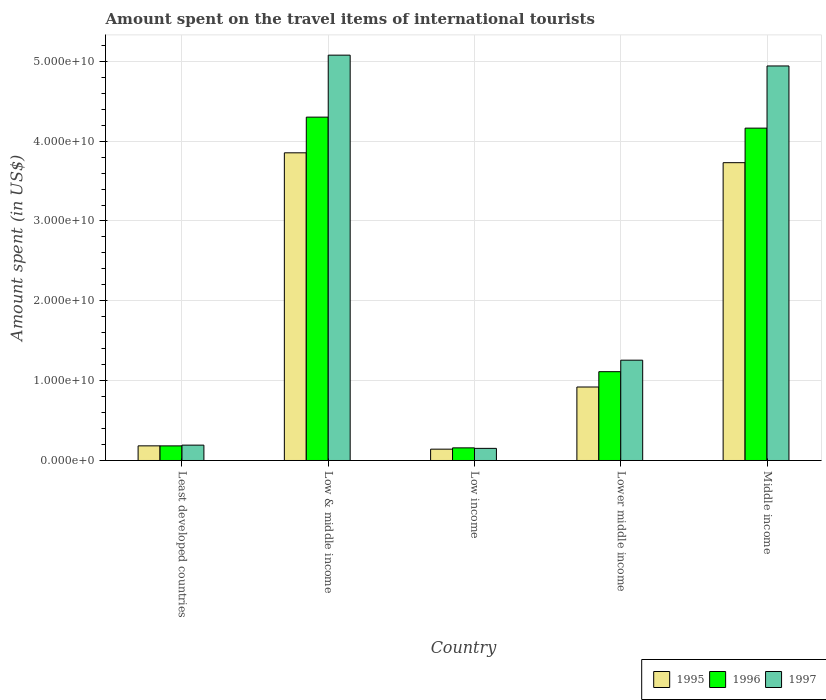How many different coloured bars are there?
Your answer should be compact. 3. How many groups of bars are there?
Ensure brevity in your answer.  5. Are the number of bars per tick equal to the number of legend labels?
Your response must be concise. Yes. What is the label of the 1st group of bars from the left?
Your answer should be very brief. Least developed countries. In how many cases, is the number of bars for a given country not equal to the number of legend labels?
Make the answer very short. 0. What is the amount spent on the travel items of international tourists in 1996 in Least developed countries?
Provide a succinct answer. 1.83e+09. Across all countries, what is the maximum amount spent on the travel items of international tourists in 1997?
Offer a very short reply. 5.08e+1. Across all countries, what is the minimum amount spent on the travel items of international tourists in 1996?
Provide a succinct answer. 1.58e+09. What is the total amount spent on the travel items of international tourists in 1996 in the graph?
Provide a succinct answer. 9.92e+1. What is the difference between the amount spent on the travel items of international tourists in 1997 in Least developed countries and that in Low & middle income?
Your answer should be compact. -4.88e+1. What is the difference between the amount spent on the travel items of international tourists in 1997 in Low income and the amount spent on the travel items of international tourists in 1995 in Least developed countries?
Your answer should be very brief. -3.15e+08. What is the average amount spent on the travel items of international tourists in 1995 per country?
Your answer should be very brief. 1.77e+1. What is the difference between the amount spent on the travel items of international tourists of/in 1996 and amount spent on the travel items of international tourists of/in 1995 in Low income?
Ensure brevity in your answer.  1.63e+08. What is the ratio of the amount spent on the travel items of international tourists in 1996 in Least developed countries to that in Lower middle income?
Your answer should be very brief. 0.16. Is the amount spent on the travel items of international tourists in 1996 in Least developed countries less than that in Low & middle income?
Provide a short and direct response. Yes. What is the difference between the highest and the second highest amount spent on the travel items of international tourists in 1997?
Keep it short and to the point. -3.69e+1. What is the difference between the highest and the lowest amount spent on the travel items of international tourists in 1995?
Provide a succinct answer. 3.71e+1. In how many countries, is the amount spent on the travel items of international tourists in 1996 greater than the average amount spent on the travel items of international tourists in 1996 taken over all countries?
Your response must be concise. 2. Is the sum of the amount spent on the travel items of international tourists in 1996 in Low income and Middle income greater than the maximum amount spent on the travel items of international tourists in 1997 across all countries?
Make the answer very short. No. Is it the case that in every country, the sum of the amount spent on the travel items of international tourists in 1996 and amount spent on the travel items of international tourists in 1997 is greater than the amount spent on the travel items of international tourists in 1995?
Your answer should be very brief. Yes. How many bars are there?
Provide a short and direct response. 15. Are all the bars in the graph horizontal?
Provide a short and direct response. No. How many countries are there in the graph?
Make the answer very short. 5. What is the difference between two consecutive major ticks on the Y-axis?
Your answer should be compact. 1.00e+1. Does the graph contain any zero values?
Provide a short and direct response. No. Where does the legend appear in the graph?
Your answer should be very brief. Bottom right. How many legend labels are there?
Offer a terse response. 3. What is the title of the graph?
Give a very brief answer. Amount spent on the travel items of international tourists. Does "2010" appear as one of the legend labels in the graph?
Provide a succinct answer. No. What is the label or title of the Y-axis?
Offer a terse response. Amount spent (in US$). What is the Amount spent (in US$) of 1995 in Least developed countries?
Offer a terse response. 1.83e+09. What is the Amount spent (in US$) of 1996 in Least developed countries?
Give a very brief answer. 1.83e+09. What is the Amount spent (in US$) in 1997 in Least developed countries?
Make the answer very short. 1.92e+09. What is the Amount spent (in US$) of 1995 in Low & middle income?
Keep it short and to the point. 3.85e+1. What is the Amount spent (in US$) of 1996 in Low & middle income?
Give a very brief answer. 4.30e+1. What is the Amount spent (in US$) of 1997 in Low & middle income?
Your response must be concise. 5.08e+1. What is the Amount spent (in US$) of 1995 in Low income?
Give a very brief answer. 1.42e+09. What is the Amount spent (in US$) of 1996 in Low income?
Your response must be concise. 1.58e+09. What is the Amount spent (in US$) of 1997 in Low income?
Your response must be concise. 1.52e+09. What is the Amount spent (in US$) of 1995 in Lower middle income?
Make the answer very short. 9.20e+09. What is the Amount spent (in US$) of 1996 in Lower middle income?
Keep it short and to the point. 1.11e+1. What is the Amount spent (in US$) in 1997 in Lower middle income?
Give a very brief answer. 1.26e+1. What is the Amount spent (in US$) in 1995 in Middle income?
Your answer should be very brief. 3.73e+1. What is the Amount spent (in US$) of 1996 in Middle income?
Offer a terse response. 4.16e+1. What is the Amount spent (in US$) of 1997 in Middle income?
Your response must be concise. 4.94e+1. Across all countries, what is the maximum Amount spent (in US$) in 1995?
Ensure brevity in your answer.  3.85e+1. Across all countries, what is the maximum Amount spent (in US$) of 1996?
Give a very brief answer. 4.30e+1. Across all countries, what is the maximum Amount spent (in US$) of 1997?
Provide a short and direct response. 5.08e+1. Across all countries, what is the minimum Amount spent (in US$) in 1995?
Ensure brevity in your answer.  1.42e+09. Across all countries, what is the minimum Amount spent (in US$) of 1996?
Offer a very short reply. 1.58e+09. Across all countries, what is the minimum Amount spent (in US$) in 1997?
Provide a short and direct response. 1.52e+09. What is the total Amount spent (in US$) of 1995 in the graph?
Make the answer very short. 8.83e+1. What is the total Amount spent (in US$) of 1996 in the graph?
Provide a short and direct response. 9.92e+1. What is the total Amount spent (in US$) in 1997 in the graph?
Your answer should be compact. 1.16e+11. What is the difference between the Amount spent (in US$) in 1995 in Least developed countries and that in Low & middle income?
Your answer should be very brief. -3.67e+1. What is the difference between the Amount spent (in US$) in 1996 in Least developed countries and that in Low & middle income?
Keep it short and to the point. -4.12e+1. What is the difference between the Amount spent (in US$) in 1997 in Least developed countries and that in Low & middle income?
Your response must be concise. -4.88e+1. What is the difference between the Amount spent (in US$) of 1995 in Least developed countries and that in Low income?
Your answer should be very brief. 4.16e+08. What is the difference between the Amount spent (in US$) of 1996 in Least developed countries and that in Low income?
Your response must be concise. 2.48e+08. What is the difference between the Amount spent (in US$) in 1997 in Least developed countries and that in Low income?
Ensure brevity in your answer.  4.05e+08. What is the difference between the Amount spent (in US$) of 1995 in Least developed countries and that in Lower middle income?
Your response must be concise. -7.37e+09. What is the difference between the Amount spent (in US$) in 1996 in Least developed countries and that in Lower middle income?
Ensure brevity in your answer.  -9.30e+09. What is the difference between the Amount spent (in US$) of 1997 in Least developed countries and that in Lower middle income?
Offer a very short reply. -1.06e+1. What is the difference between the Amount spent (in US$) of 1995 in Least developed countries and that in Middle income?
Give a very brief answer. -3.55e+1. What is the difference between the Amount spent (in US$) of 1996 in Least developed countries and that in Middle income?
Provide a short and direct response. -3.98e+1. What is the difference between the Amount spent (in US$) of 1997 in Least developed countries and that in Middle income?
Provide a short and direct response. -4.75e+1. What is the difference between the Amount spent (in US$) in 1995 in Low & middle income and that in Low income?
Ensure brevity in your answer.  3.71e+1. What is the difference between the Amount spent (in US$) in 1996 in Low & middle income and that in Low income?
Offer a terse response. 4.14e+1. What is the difference between the Amount spent (in US$) of 1997 in Low & middle income and that in Low income?
Offer a terse response. 4.93e+1. What is the difference between the Amount spent (in US$) in 1995 in Low & middle income and that in Lower middle income?
Your response must be concise. 2.93e+1. What is the difference between the Amount spent (in US$) in 1996 in Low & middle income and that in Lower middle income?
Keep it short and to the point. 3.19e+1. What is the difference between the Amount spent (in US$) in 1997 in Low & middle income and that in Lower middle income?
Offer a terse response. 3.82e+1. What is the difference between the Amount spent (in US$) in 1995 in Low & middle income and that in Middle income?
Your answer should be very brief. 1.24e+09. What is the difference between the Amount spent (in US$) of 1996 in Low & middle income and that in Middle income?
Offer a very short reply. 1.38e+09. What is the difference between the Amount spent (in US$) in 1997 in Low & middle income and that in Middle income?
Offer a very short reply. 1.36e+09. What is the difference between the Amount spent (in US$) in 1995 in Low income and that in Lower middle income?
Keep it short and to the point. -7.79e+09. What is the difference between the Amount spent (in US$) in 1996 in Low income and that in Lower middle income?
Give a very brief answer. -9.54e+09. What is the difference between the Amount spent (in US$) of 1997 in Low income and that in Lower middle income?
Offer a very short reply. -1.10e+1. What is the difference between the Amount spent (in US$) of 1995 in Low income and that in Middle income?
Offer a very short reply. -3.59e+1. What is the difference between the Amount spent (in US$) in 1996 in Low income and that in Middle income?
Your answer should be compact. -4.00e+1. What is the difference between the Amount spent (in US$) in 1997 in Low income and that in Middle income?
Offer a terse response. -4.79e+1. What is the difference between the Amount spent (in US$) in 1995 in Lower middle income and that in Middle income?
Your response must be concise. -2.81e+1. What is the difference between the Amount spent (in US$) of 1996 in Lower middle income and that in Middle income?
Your response must be concise. -3.05e+1. What is the difference between the Amount spent (in US$) in 1997 in Lower middle income and that in Middle income?
Your response must be concise. -3.69e+1. What is the difference between the Amount spent (in US$) in 1995 in Least developed countries and the Amount spent (in US$) in 1996 in Low & middle income?
Your answer should be compact. -4.12e+1. What is the difference between the Amount spent (in US$) in 1995 in Least developed countries and the Amount spent (in US$) in 1997 in Low & middle income?
Offer a very short reply. -4.89e+1. What is the difference between the Amount spent (in US$) in 1996 in Least developed countries and the Amount spent (in US$) in 1997 in Low & middle income?
Your answer should be compact. -4.89e+1. What is the difference between the Amount spent (in US$) in 1995 in Least developed countries and the Amount spent (in US$) in 1996 in Low income?
Ensure brevity in your answer.  2.52e+08. What is the difference between the Amount spent (in US$) of 1995 in Least developed countries and the Amount spent (in US$) of 1997 in Low income?
Ensure brevity in your answer.  3.15e+08. What is the difference between the Amount spent (in US$) in 1996 in Least developed countries and the Amount spent (in US$) in 1997 in Low income?
Keep it short and to the point. 3.11e+08. What is the difference between the Amount spent (in US$) in 1995 in Least developed countries and the Amount spent (in US$) in 1996 in Lower middle income?
Make the answer very short. -9.29e+09. What is the difference between the Amount spent (in US$) of 1995 in Least developed countries and the Amount spent (in US$) of 1997 in Lower middle income?
Offer a terse response. -1.07e+1. What is the difference between the Amount spent (in US$) in 1996 in Least developed countries and the Amount spent (in US$) in 1997 in Lower middle income?
Offer a very short reply. -1.07e+1. What is the difference between the Amount spent (in US$) of 1995 in Least developed countries and the Amount spent (in US$) of 1996 in Middle income?
Provide a short and direct response. -3.98e+1. What is the difference between the Amount spent (in US$) in 1995 in Least developed countries and the Amount spent (in US$) in 1997 in Middle income?
Make the answer very short. -4.76e+1. What is the difference between the Amount spent (in US$) in 1996 in Least developed countries and the Amount spent (in US$) in 1997 in Middle income?
Make the answer very short. -4.76e+1. What is the difference between the Amount spent (in US$) of 1995 in Low & middle income and the Amount spent (in US$) of 1996 in Low income?
Offer a very short reply. 3.70e+1. What is the difference between the Amount spent (in US$) of 1995 in Low & middle income and the Amount spent (in US$) of 1997 in Low income?
Ensure brevity in your answer.  3.70e+1. What is the difference between the Amount spent (in US$) in 1996 in Low & middle income and the Amount spent (in US$) in 1997 in Low income?
Provide a short and direct response. 4.15e+1. What is the difference between the Amount spent (in US$) in 1995 in Low & middle income and the Amount spent (in US$) in 1996 in Lower middle income?
Provide a short and direct response. 2.74e+1. What is the difference between the Amount spent (in US$) in 1995 in Low & middle income and the Amount spent (in US$) in 1997 in Lower middle income?
Your response must be concise. 2.60e+1. What is the difference between the Amount spent (in US$) of 1996 in Low & middle income and the Amount spent (in US$) of 1997 in Lower middle income?
Provide a succinct answer. 3.04e+1. What is the difference between the Amount spent (in US$) of 1995 in Low & middle income and the Amount spent (in US$) of 1996 in Middle income?
Give a very brief answer. -3.09e+09. What is the difference between the Amount spent (in US$) in 1995 in Low & middle income and the Amount spent (in US$) in 1997 in Middle income?
Your response must be concise. -1.09e+1. What is the difference between the Amount spent (in US$) in 1996 in Low & middle income and the Amount spent (in US$) in 1997 in Middle income?
Make the answer very short. -6.41e+09. What is the difference between the Amount spent (in US$) of 1995 in Low income and the Amount spent (in US$) of 1996 in Lower middle income?
Your answer should be very brief. -9.71e+09. What is the difference between the Amount spent (in US$) of 1995 in Low income and the Amount spent (in US$) of 1997 in Lower middle income?
Keep it short and to the point. -1.11e+1. What is the difference between the Amount spent (in US$) of 1996 in Low income and the Amount spent (in US$) of 1997 in Lower middle income?
Give a very brief answer. -1.10e+1. What is the difference between the Amount spent (in US$) of 1995 in Low income and the Amount spent (in US$) of 1996 in Middle income?
Offer a terse response. -4.02e+1. What is the difference between the Amount spent (in US$) of 1995 in Low income and the Amount spent (in US$) of 1997 in Middle income?
Your response must be concise. -4.80e+1. What is the difference between the Amount spent (in US$) in 1996 in Low income and the Amount spent (in US$) in 1997 in Middle income?
Offer a very short reply. -4.78e+1. What is the difference between the Amount spent (in US$) in 1995 in Lower middle income and the Amount spent (in US$) in 1996 in Middle income?
Offer a very short reply. -3.24e+1. What is the difference between the Amount spent (in US$) in 1995 in Lower middle income and the Amount spent (in US$) in 1997 in Middle income?
Give a very brief answer. -4.02e+1. What is the difference between the Amount spent (in US$) of 1996 in Lower middle income and the Amount spent (in US$) of 1997 in Middle income?
Give a very brief answer. -3.83e+1. What is the average Amount spent (in US$) of 1995 per country?
Make the answer very short. 1.77e+1. What is the average Amount spent (in US$) of 1996 per country?
Give a very brief answer. 1.98e+1. What is the average Amount spent (in US$) of 1997 per country?
Give a very brief answer. 2.32e+1. What is the difference between the Amount spent (in US$) in 1995 and Amount spent (in US$) in 1996 in Least developed countries?
Your response must be concise. 4.74e+06. What is the difference between the Amount spent (in US$) in 1995 and Amount spent (in US$) in 1997 in Least developed countries?
Keep it short and to the point. -9.00e+07. What is the difference between the Amount spent (in US$) in 1996 and Amount spent (in US$) in 1997 in Least developed countries?
Ensure brevity in your answer.  -9.47e+07. What is the difference between the Amount spent (in US$) in 1995 and Amount spent (in US$) in 1996 in Low & middle income?
Keep it short and to the point. -4.47e+09. What is the difference between the Amount spent (in US$) of 1995 and Amount spent (in US$) of 1997 in Low & middle income?
Give a very brief answer. -1.22e+1. What is the difference between the Amount spent (in US$) in 1996 and Amount spent (in US$) in 1997 in Low & middle income?
Keep it short and to the point. -7.77e+09. What is the difference between the Amount spent (in US$) in 1995 and Amount spent (in US$) in 1996 in Low income?
Your response must be concise. -1.63e+08. What is the difference between the Amount spent (in US$) of 1995 and Amount spent (in US$) of 1997 in Low income?
Offer a terse response. -1.00e+08. What is the difference between the Amount spent (in US$) of 1996 and Amount spent (in US$) of 1997 in Low income?
Keep it short and to the point. 6.31e+07. What is the difference between the Amount spent (in US$) in 1995 and Amount spent (in US$) in 1996 in Lower middle income?
Offer a terse response. -1.92e+09. What is the difference between the Amount spent (in US$) of 1995 and Amount spent (in US$) of 1997 in Lower middle income?
Offer a very short reply. -3.36e+09. What is the difference between the Amount spent (in US$) in 1996 and Amount spent (in US$) in 1997 in Lower middle income?
Make the answer very short. -1.44e+09. What is the difference between the Amount spent (in US$) in 1995 and Amount spent (in US$) in 1996 in Middle income?
Your response must be concise. -4.33e+09. What is the difference between the Amount spent (in US$) in 1995 and Amount spent (in US$) in 1997 in Middle income?
Provide a short and direct response. -1.21e+1. What is the difference between the Amount spent (in US$) of 1996 and Amount spent (in US$) of 1997 in Middle income?
Offer a terse response. -7.79e+09. What is the ratio of the Amount spent (in US$) in 1995 in Least developed countries to that in Low & middle income?
Your answer should be compact. 0.05. What is the ratio of the Amount spent (in US$) of 1996 in Least developed countries to that in Low & middle income?
Your answer should be compact. 0.04. What is the ratio of the Amount spent (in US$) of 1997 in Least developed countries to that in Low & middle income?
Your response must be concise. 0.04. What is the ratio of the Amount spent (in US$) in 1995 in Least developed countries to that in Low income?
Keep it short and to the point. 1.29. What is the ratio of the Amount spent (in US$) of 1996 in Least developed countries to that in Low income?
Offer a terse response. 1.16. What is the ratio of the Amount spent (in US$) in 1997 in Least developed countries to that in Low income?
Your answer should be very brief. 1.27. What is the ratio of the Amount spent (in US$) in 1995 in Least developed countries to that in Lower middle income?
Keep it short and to the point. 0.2. What is the ratio of the Amount spent (in US$) in 1996 in Least developed countries to that in Lower middle income?
Ensure brevity in your answer.  0.16. What is the ratio of the Amount spent (in US$) of 1997 in Least developed countries to that in Lower middle income?
Provide a short and direct response. 0.15. What is the ratio of the Amount spent (in US$) of 1995 in Least developed countries to that in Middle income?
Keep it short and to the point. 0.05. What is the ratio of the Amount spent (in US$) of 1996 in Least developed countries to that in Middle income?
Your answer should be very brief. 0.04. What is the ratio of the Amount spent (in US$) in 1997 in Least developed countries to that in Middle income?
Provide a succinct answer. 0.04. What is the ratio of the Amount spent (in US$) of 1995 in Low & middle income to that in Low income?
Your response must be concise. 27.18. What is the ratio of the Amount spent (in US$) of 1996 in Low & middle income to that in Low income?
Make the answer very short. 27.2. What is the ratio of the Amount spent (in US$) of 1997 in Low & middle income to that in Low income?
Make the answer very short. 33.45. What is the ratio of the Amount spent (in US$) of 1995 in Low & middle income to that in Lower middle income?
Offer a very short reply. 4.19. What is the ratio of the Amount spent (in US$) in 1996 in Low & middle income to that in Lower middle income?
Your answer should be compact. 3.87. What is the ratio of the Amount spent (in US$) of 1997 in Low & middle income to that in Lower middle income?
Provide a short and direct response. 4.04. What is the ratio of the Amount spent (in US$) of 1995 in Low & middle income to that in Middle income?
Your answer should be compact. 1.03. What is the ratio of the Amount spent (in US$) in 1996 in Low & middle income to that in Middle income?
Offer a very short reply. 1.03. What is the ratio of the Amount spent (in US$) in 1997 in Low & middle income to that in Middle income?
Provide a succinct answer. 1.03. What is the ratio of the Amount spent (in US$) of 1995 in Low income to that in Lower middle income?
Ensure brevity in your answer.  0.15. What is the ratio of the Amount spent (in US$) in 1996 in Low income to that in Lower middle income?
Give a very brief answer. 0.14. What is the ratio of the Amount spent (in US$) in 1997 in Low income to that in Lower middle income?
Ensure brevity in your answer.  0.12. What is the ratio of the Amount spent (in US$) of 1995 in Low income to that in Middle income?
Your response must be concise. 0.04. What is the ratio of the Amount spent (in US$) of 1996 in Low income to that in Middle income?
Your answer should be compact. 0.04. What is the ratio of the Amount spent (in US$) of 1997 in Low income to that in Middle income?
Ensure brevity in your answer.  0.03. What is the ratio of the Amount spent (in US$) in 1995 in Lower middle income to that in Middle income?
Provide a short and direct response. 0.25. What is the ratio of the Amount spent (in US$) in 1996 in Lower middle income to that in Middle income?
Provide a succinct answer. 0.27. What is the ratio of the Amount spent (in US$) in 1997 in Lower middle income to that in Middle income?
Provide a short and direct response. 0.25. What is the difference between the highest and the second highest Amount spent (in US$) of 1995?
Make the answer very short. 1.24e+09. What is the difference between the highest and the second highest Amount spent (in US$) of 1996?
Ensure brevity in your answer.  1.38e+09. What is the difference between the highest and the second highest Amount spent (in US$) in 1997?
Provide a short and direct response. 1.36e+09. What is the difference between the highest and the lowest Amount spent (in US$) of 1995?
Your response must be concise. 3.71e+1. What is the difference between the highest and the lowest Amount spent (in US$) in 1996?
Provide a succinct answer. 4.14e+1. What is the difference between the highest and the lowest Amount spent (in US$) of 1997?
Make the answer very short. 4.93e+1. 